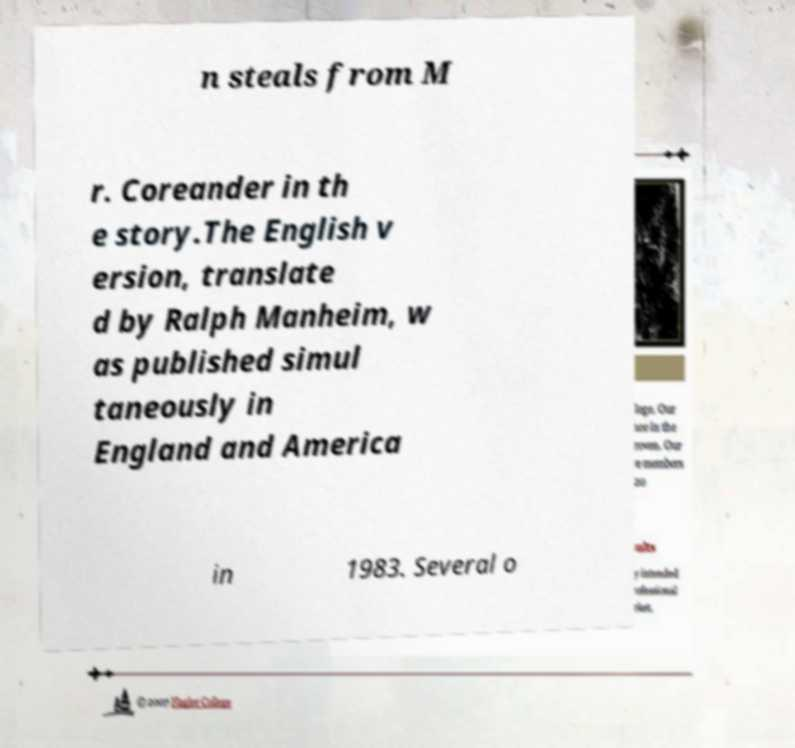Can you accurately transcribe the text from the provided image for me? n steals from M r. Coreander in th e story.The English v ersion, translate d by Ralph Manheim, w as published simul taneously in England and America in 1983. Several o 